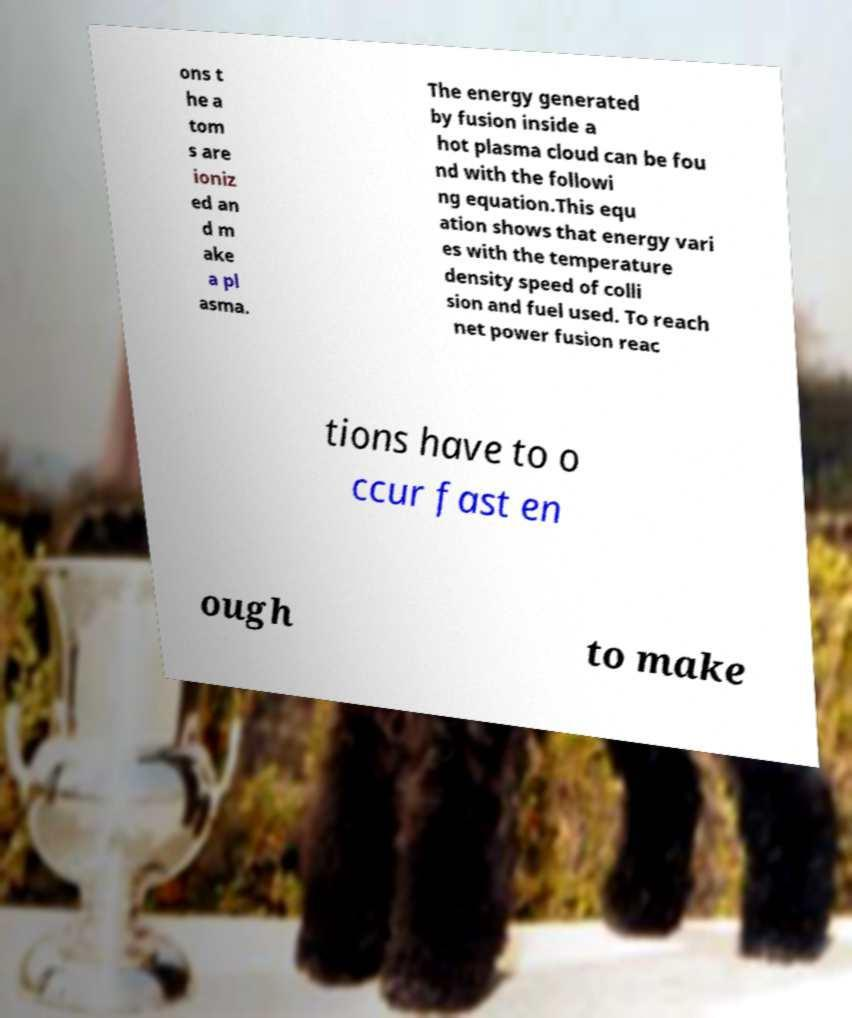I need the written content from this picture converted into text. Can you do that? ons t he a tom s are ioniz ed an d m ake a pl asma. The energy generated by fusion inside a hot plasma cloud can be fou nd with the followi ng equation.This equ ation shows that energy vari es with the temperature density speed of colli sion and fuel used. To reach net power fusion reac tions have to o ccur fast en ough to make 